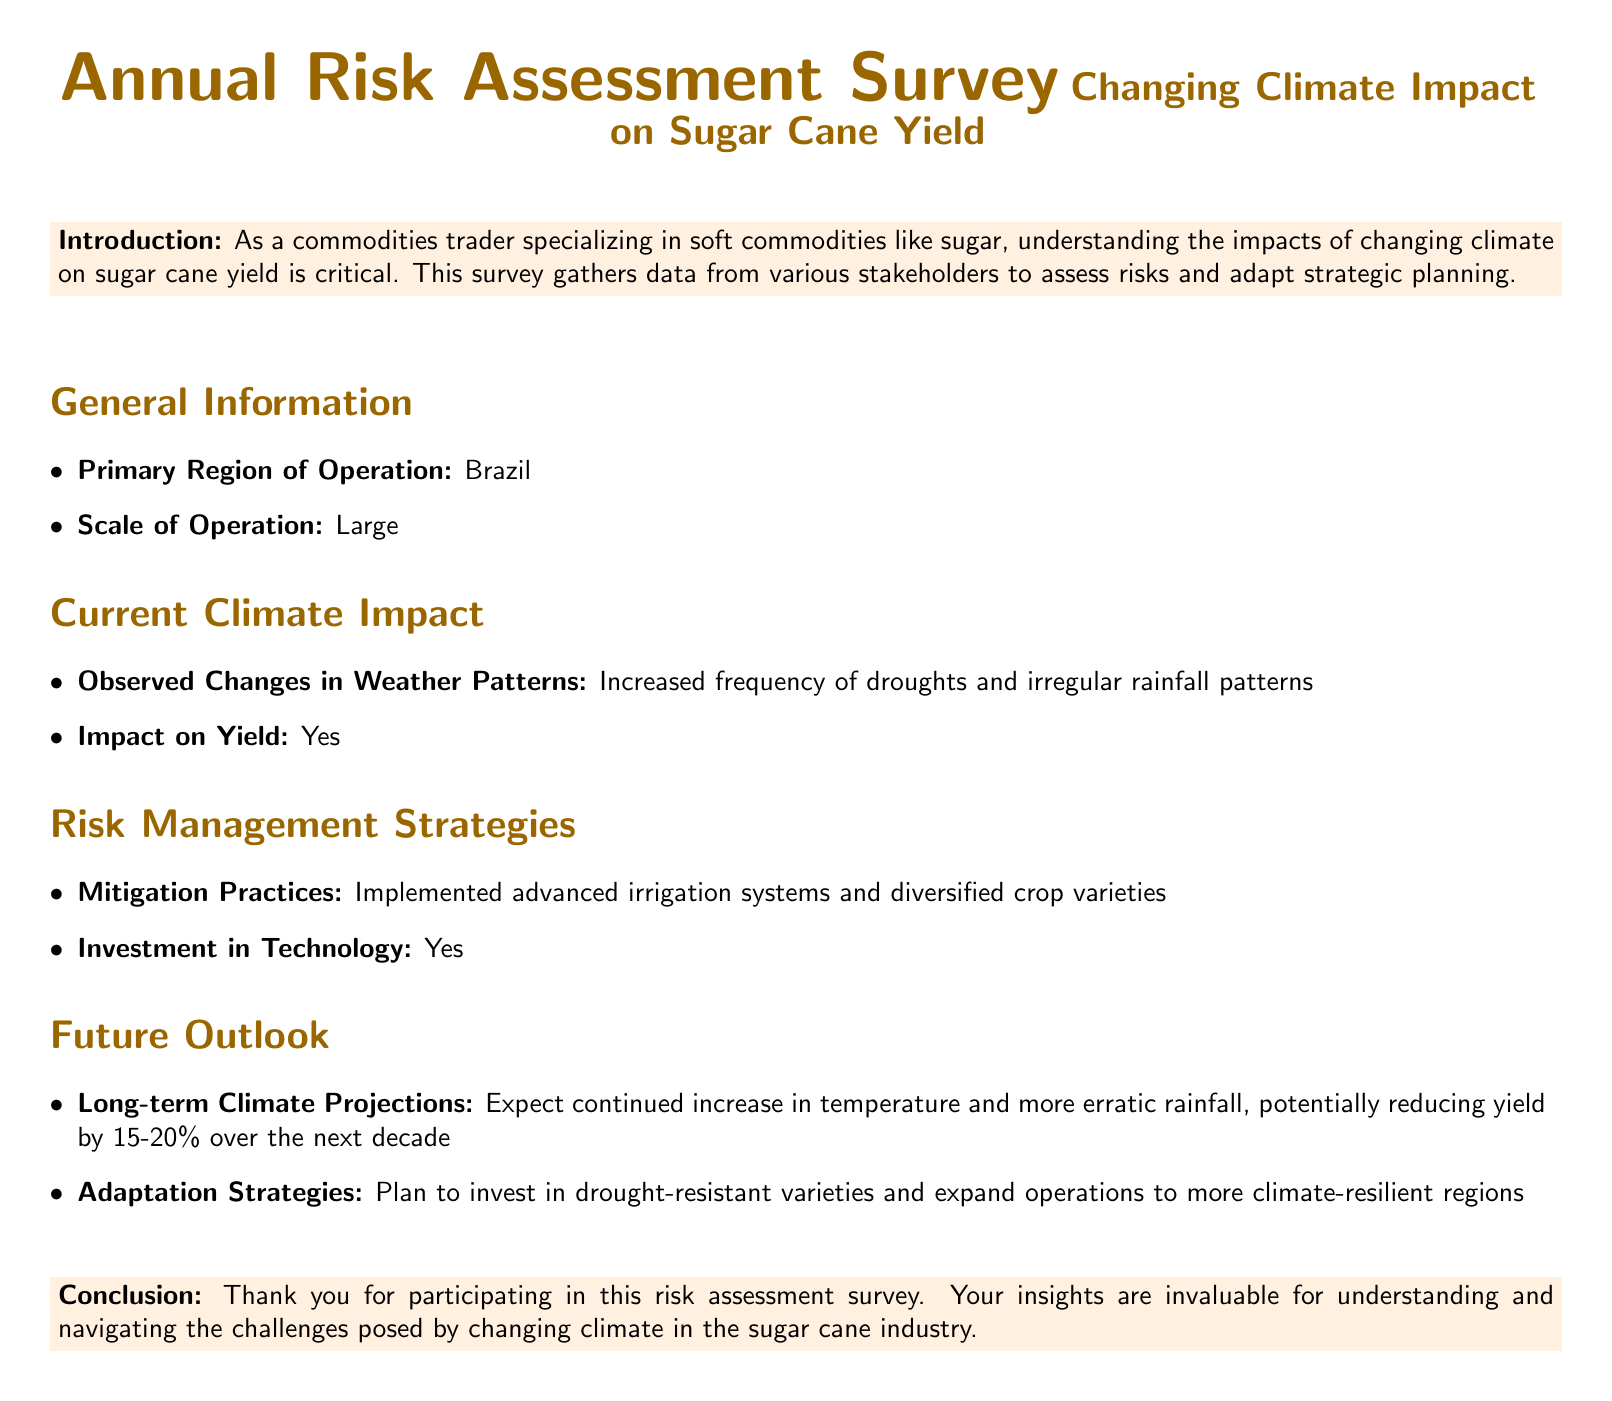what is the primary region of operation? The primary region of operation is stated in the General Information section of the document as Brazil.
Answer: Brazil what is the scale of operation? The scale of operation is also provided in the General Information section and categorized as Large.
Answer: Large what changes in weather patterns have been observed? The observed changes in weather patterns are noted in the Current Climate Impact section, specifically increased frequency of droughts and irregular rainfall patterns.
Answer: Increased frequency of droughts and irregular rainfall patterns what is the expected reduction in yield over the next decade? The long-term climate projections indicate a potential reduction of yield by 15-20% over the next decade, as mentioned in the Future Outlook section.
Answer: 15-20% what adaptation strategies are planned? The planned adaptation strategies include investing in drought-resistant varieties and expanding operations to more climate-resilient regions, as detailed in the Future Outlook section.
Answer: Invest in drought-resistant varieties and expand operations to more climate-resilient regions how does the document categorize risk management strategies? The document lists risk management strategies under the section titled Risk Management Strategies, which includes mitigation practices and technology investment.
Answer: Mitigation practices and investment in technology is there a conclusion section in the document? The document concludes with a section titled Conclusion, which thanks participants for their insights, confirming the presence of a conclusion.
Answer: Yes what is mentioned about investment in technology? The document states in the Risk Management Strategies section that there has been an investment in technology.
Answer: Yes 